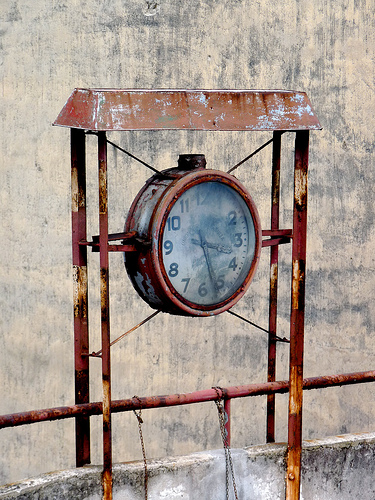Describe the overall condition of the clock and its immediate surroundings. The clock exhibits a significant degree of wear, with a rusted and corroded metal frame and a foggy, somewhat dirt-smeared glass cover. The area around the clock is similarly weathered, with discolored and degraded surfaces indicating long-term exposure to the elements. 